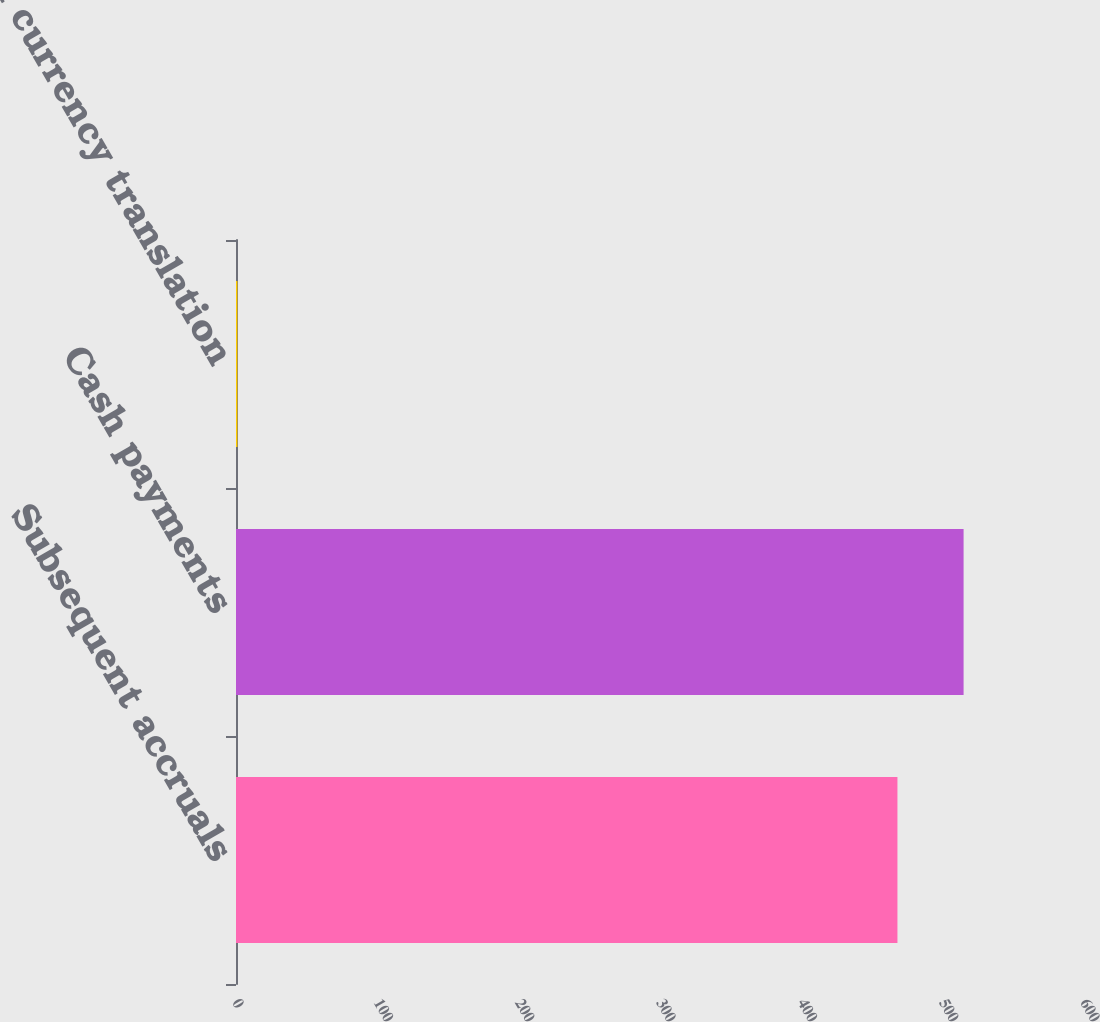Convert chart. <chart><loc_0><loc_0><loc_500><loc_500><bar_chart><fcel>Subsequent accruals<fcel>Cash payments<fcel>Foreign currency translation<nl><fcel>468<fcel>514.8<fcel>1<nl></chart> 